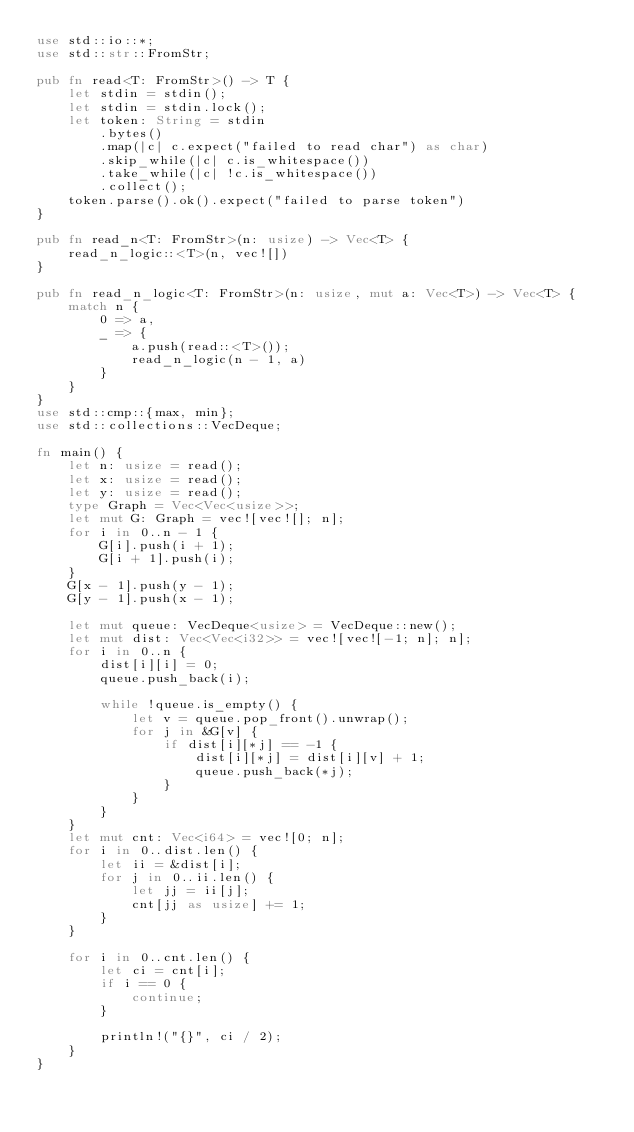<code> <loc_0><loc_0><loc_500><loc_500><_Rust_>use std::io::*;
use std::str::FromStr;

pub fn read<T: FromStr>() -> T {
    let stdin = stdin();
    let stdin = stdin.lock();
    let token: String = stdin
        .bytes()
        .map(|c| c.expect("failed to read char") as char)
        .skip_while(|c| c.is_whitespace())
        .take_while(|c| !c.is_whitespace())
        .collect();
    token.parse().ok().expect("failed to parse token")
}

pub fn read_n<T: FromStr>(n: usize) -> Vec<T> {
    read_n_logic::<T>(n, vec![])
}

pub fn read_n_logic<T: FromStr>(n: usize, mut a: Vec<T>) -> Vec<T> {
    match n {
        0 => a,
        _ => {
            a.push(read::<T>());
            read_n_logic(n - 1, a)
        }
    }
}
use std::cmp::{max, min};
use std::collections::VecDeque;

fn main() {
    let n: usize = read();
    let x: usize = read();
    let y: usize = read();
    type Graph = Vec<Vec<usize>>;
    let mut G: Graph = vec![vec![]; n];
    for i in 0..n - 1 {
        G[i].push(i + 1);
        G[i + 1].push(i);
    }
    G[x - 1].push(y - 1);
    G[y - 1].push(x - 1);

    let mut queue: VecDeque<usize> = VecDeque::new();
    let mut dist: Vec<Vec<i32>> = vec![vec![-1; n]; n];
    for i in 0..n {
        dist[i][i] = 0;
        queue.push_back(i);

        while !queue.is_empty() {
            let v = queue.pop_front().unwrap();
            for j in &G[v] {
                if dist[i][*j] == -1 {
                    dist[i][*j] = dist[i][v] + 1;
                    queue.push_back(*j);
                }
            }
        }
    }
    let mut cnt: Vec<i64> = vec![0; n];
    for i in 0..dist.len() {
        let ii = &dist[i];
        for j in 0..ii.len() {
            let jj = ii[j];
            cnt[jj as usize] += 1;
        }
    }

    for i in 0..cnt.len() {
        let ci = cnt[i];
        if i == 0 {
            continue;
        }

        println!("{}", ci / 2);
    }
}
</code> 